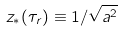Convert formula to latex. <formula><loc_0><loc_0><loc_500><loc_500>z _ { * } ( \tau _ { r } ) \equiv 1 / \sqrt { a ^ { 2 } }</formula> 